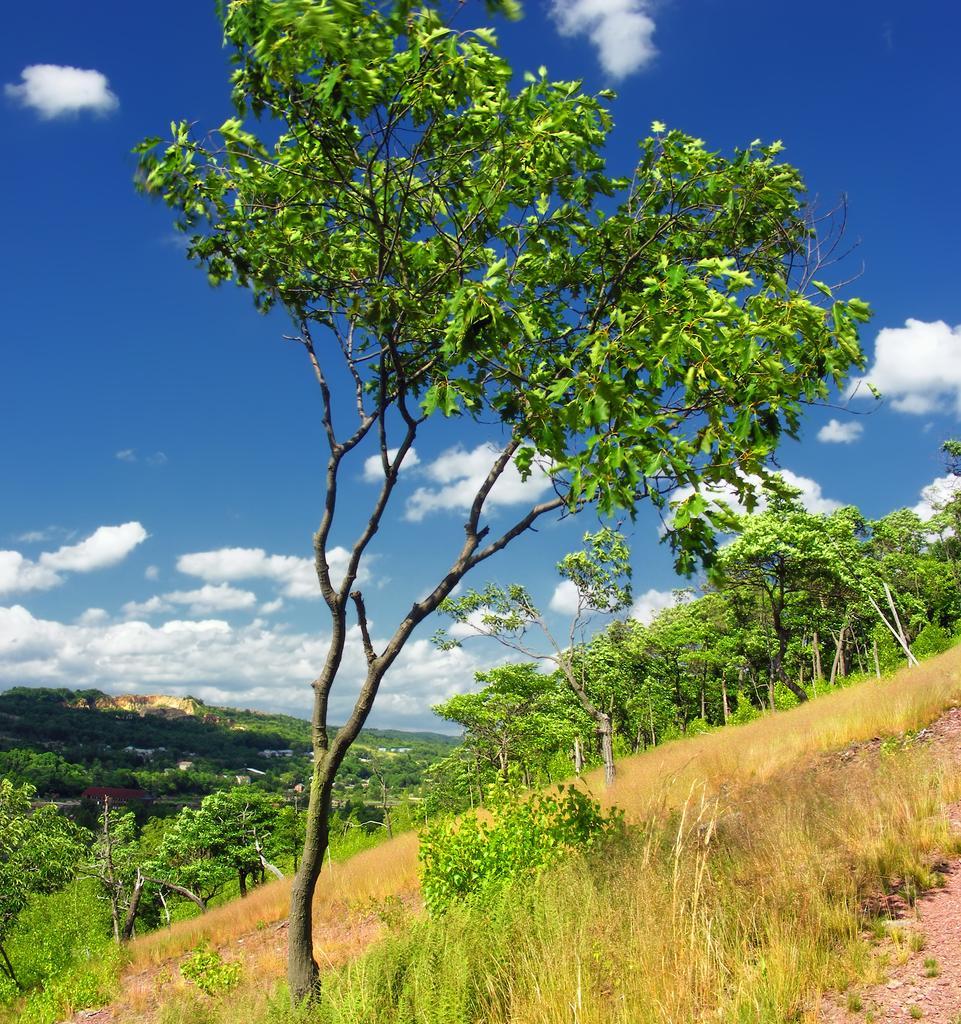In one or two sentences, can you explain what this image depicts? In the foreground of this image, there is greenery on the slope surface and we can also see grass. In the background, there is greenery, sky and the cloud. 